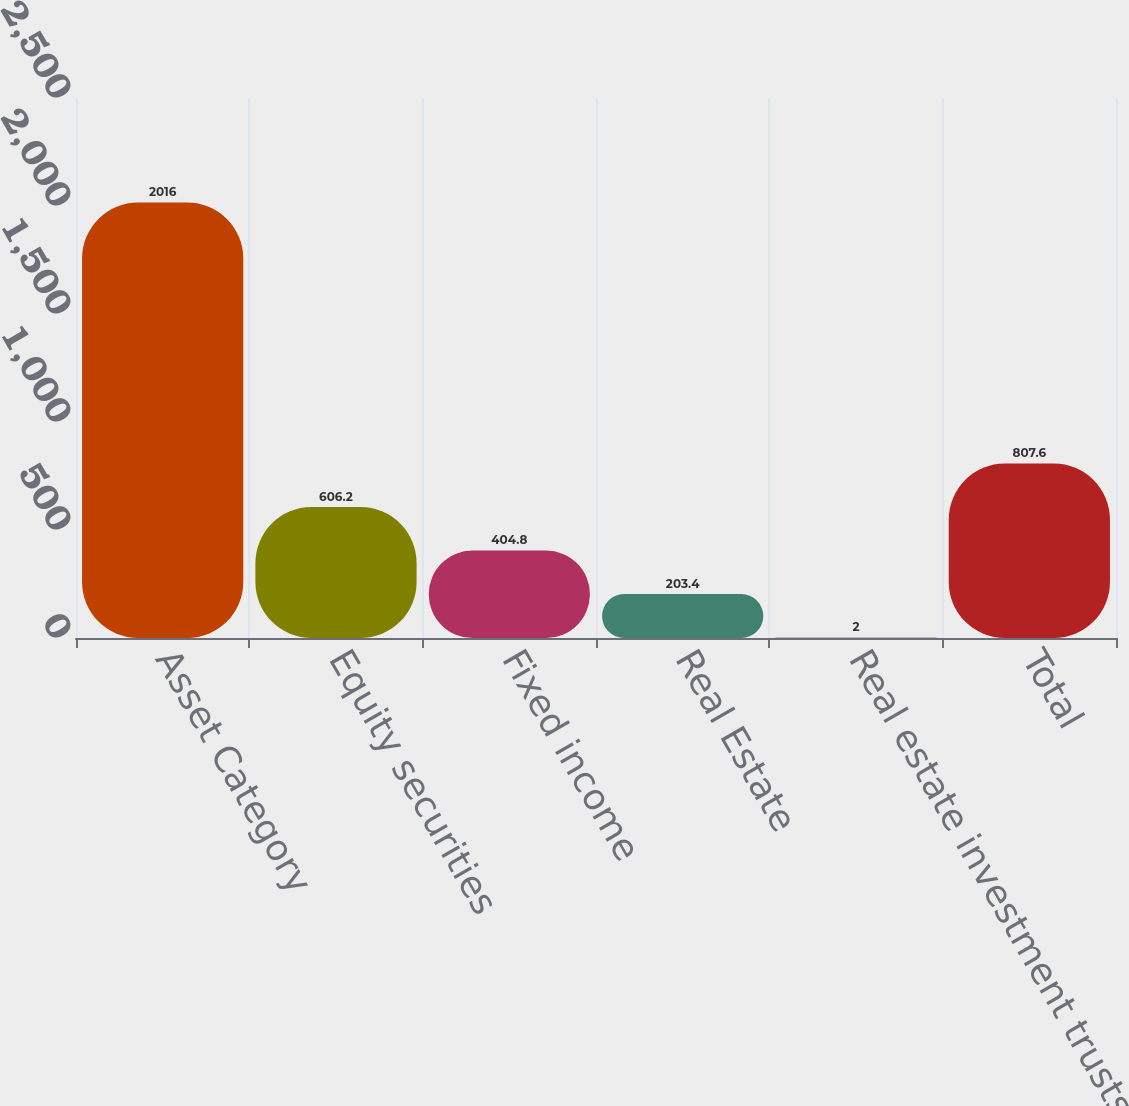<chart> <loc_0><loc_0><loc_500><loc_500><bar_chart><fcel>Asset Category<fcel>Equity securities<fcel>Fixed income<fcel>Real Estate<fcel>Real estate investment trusts<fcel>Total<nl><fcel>2016<fcel>606.2<fcel>404.8<fcel>203.4<fcel>2<fcel>807.6<nl></chart> 